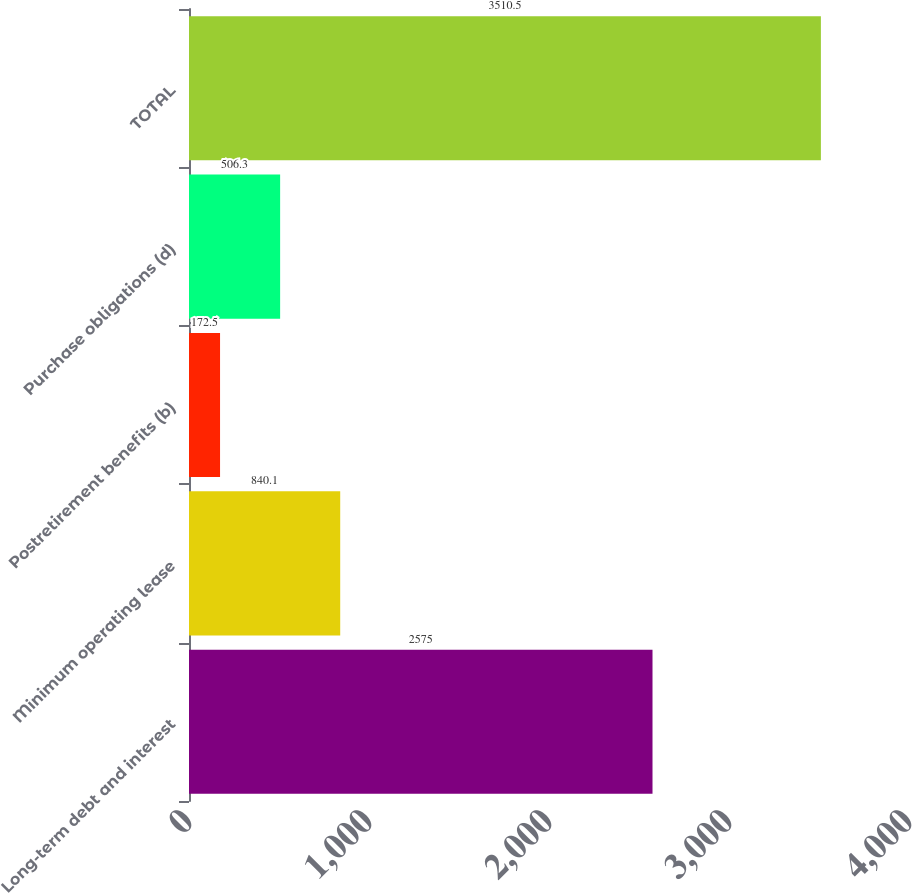<chart> <loc_0><loc_0><loc_500><loc_500><bar_chart><fcel>Long-term debt and interest<fcel>Minimum operating lease<fcel>Postretirement benefits (b)<fcel>Purchase obligations (d)<fcel>TOTAL<nl><fcel>2575<fcel>840.1<fcel>172.5<fcel>506.3<fcel>3510.5<nl></chart> 